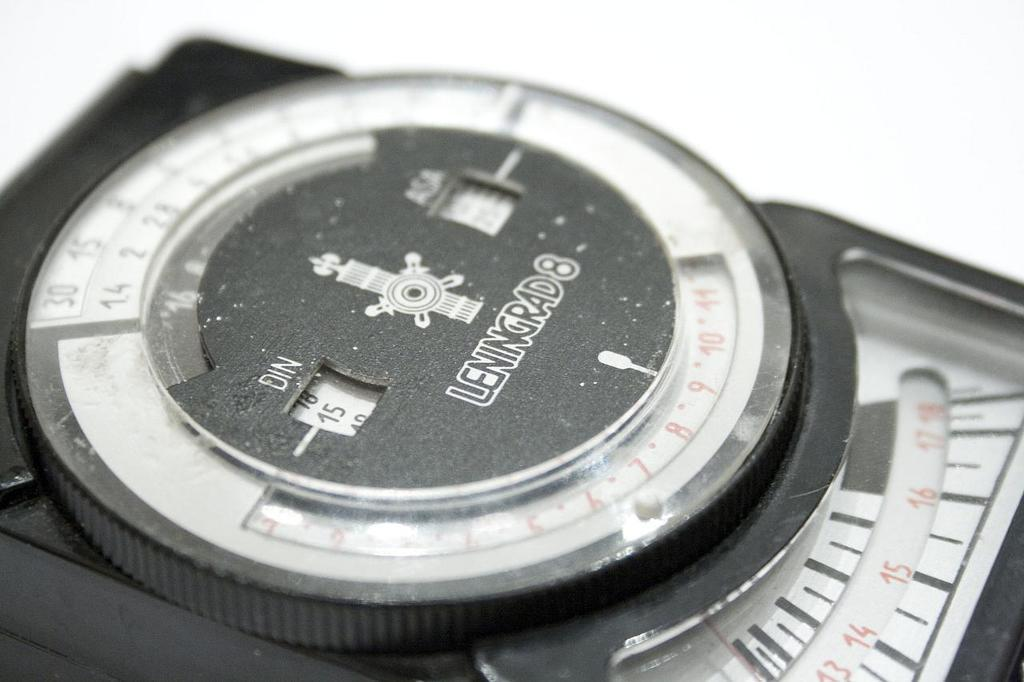Provide a one-sentence caption for the provided image. A machine showing the number 15 is sitting on a table. 